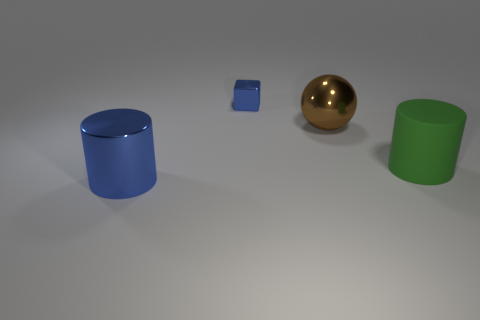Are there any other things that have the same material as the big green object?
Offer a very short reply. No. Are there any other things that have the same size as the blue metallic block?
Your answer should be very brief. No. What is the large brown ball made of?
Your answer should be compact. Metal. What number of metal blocks are on the left side of the large brown metallic ball?
Provide a succinct answer. 1. Does the small shiny cube have the same color as the large sphere?
Your response must be concise. No. How many shiny cylinders are the same color as the metal block?
Ensure brevity in your answer.  1. Are there more small brown rubber blocks than tiny metallic things?
Offer a very short reply. No. There is a object that is both to the right of the tiny object and on the left side of the big matte object; what size is it?
Provide a succinct answer. Large. Are the blue thing that is behind the big brown shiny object and the big cylinder to the left of the big metal ball made of the same material?
Your answer should be very brief. Yes. There is a matte thing that is the same size as the metallic cylinder; what is its shape?
Your answer should be compact. Cylinder. 